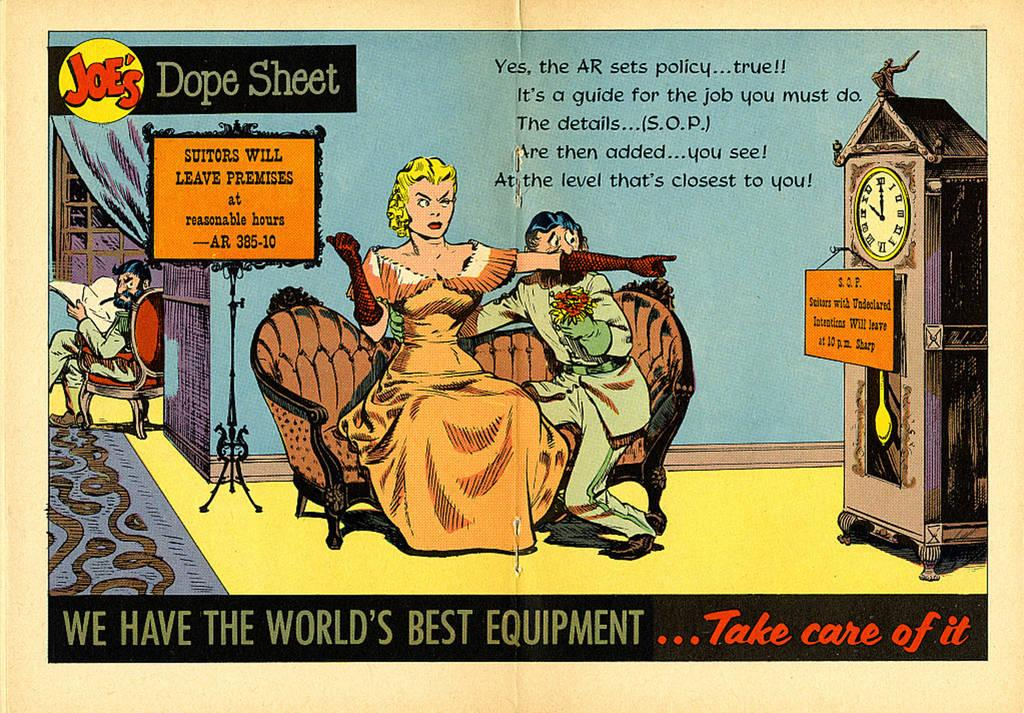Provide a one-sentence caption for the provided image. Joe's Dope Sheet offers a satire cartoon about a Victorian woman. 